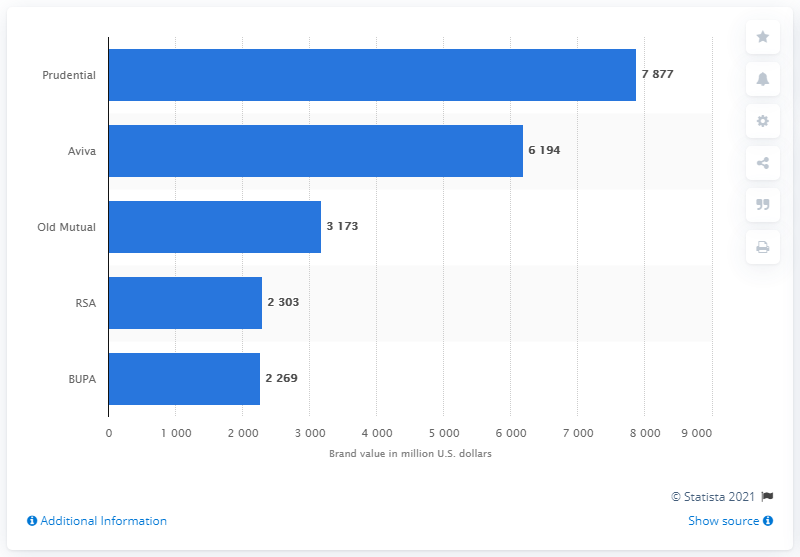Which brand has the least value and what does the value stand for? According to the image, BUPA has the least brand value among the listed companies, with a value of approximately $2.269 billion USD. The values on the chart represent the monetary valuation of each company's brand in million U.S. dollars. 